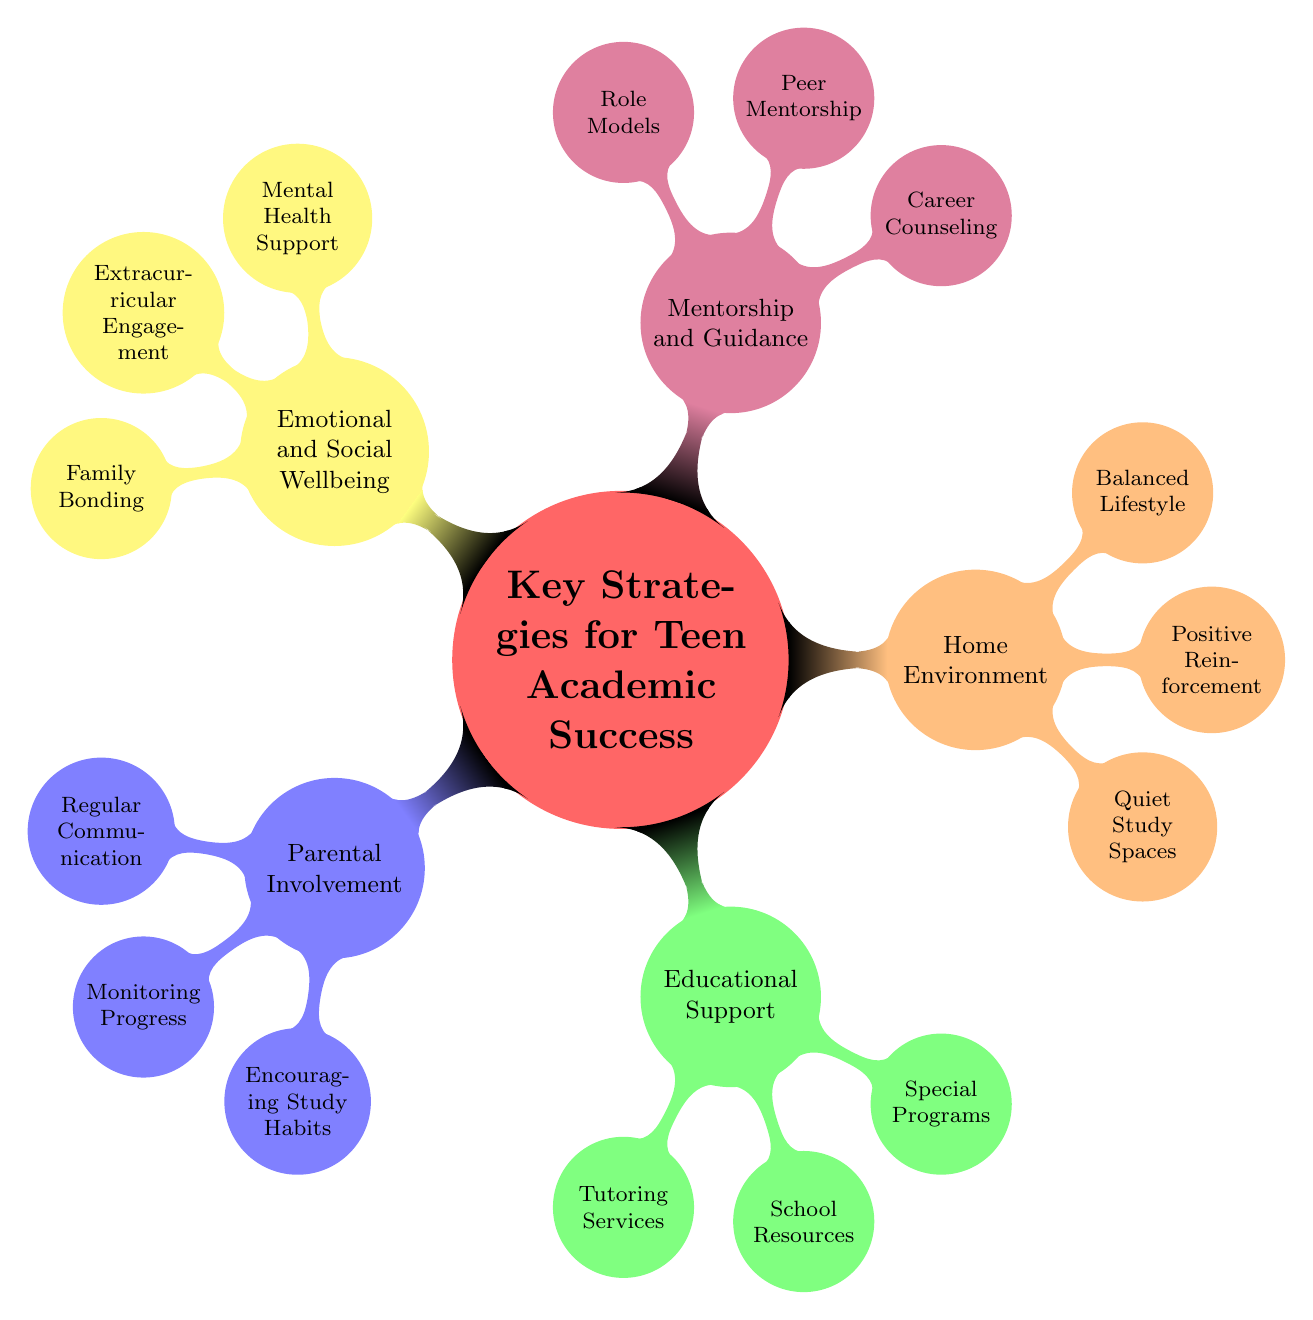What are the main categories of strategies in the diagram? The diagram has five main categories represented in the first level, which are Parental Involvement, Educational Support, Home Environment, Mentorship and Guidance, and Emotional and Social Wellbeing.
Answer: Five What is one approach under "Parental Involvement"? "Parental Involvement" includes several approaches, one of which is "Monitoring Academic Progress." This can be deduced by examining the child nodes under the "Parental Involvement" parent node.
Answer: Monitoring Academic Progress How many child nodes are there under "Educational Support"? Under "Educational Support," there are three child nodes listed: "Tutoring Services," "Utilizing School Resources," and "Special Programs." This is counted directly from the branch under "Educational Support."
Answer: Three Which node is related to "Mental Health Support"? "Mental Health Support" is a child node under the "Emotional and Social Wellbeing" category, indicating that it deals with mental health resources for teens. This is found by following the connections from "Emotional and Social Wellbeing."
Answer: Emotional and Social Wellbeing How is "Positive Reinforcement" categorized? "Positive Reinforcement" is categorized under "Home Environment" as one of the strategies to support teen academic success. This is identified by looking at the second level of nodes stemming from "Home Environment."
Answer: Home Environment What strategy involves family dinners? The strategy that involves family dinners is found under "Emotional and Social Wellbeing," specifically related to the "Family Bonding" node. This connection can be traced from the top level down to the corresponding child node.
Answer: Family Bonding What is a benefit of "Peer Mentorship"? A benefit of "Peer Mentorship" is likely to facilitate collaborative learning among students, aiding in academic success. This can be inferred by its placement as a supportive strategy under "Mentorship and Guidance."
Answer: Collaborative learning Which category represents support for balancing school and personal life? The category that represents support for balancing school and personal life is "Emotional and Social Wellbeing," as it includes strategies that promote overall wellness in addition to academic efforts. This is understood by analyzing the intent behind the node titles.
Answer: Emotional and Social Wellbeing What type of counseling is provided under "Mentorship and Guidance"? "Career Counseling" is the type of counseling provided under "Mentorship and Guidance." This relationship is straightforwardly established by observing the direct connection between these nodes in the diagram.
Answer: Career Counseling 